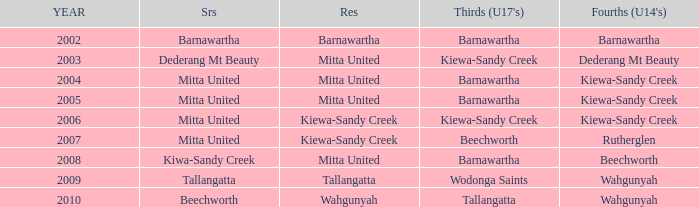Which seniors have a year after 2005, a Reserve of kiewa-sandy creek, and Fourths (Under 14's) of kiewa-sandy creek? Mitta United. 